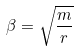Convert formula to latex. <formula><loc_0><loc_0><loc_500><loc_500>\beta = \sqrt { \frac { m } { r } }</formula> 